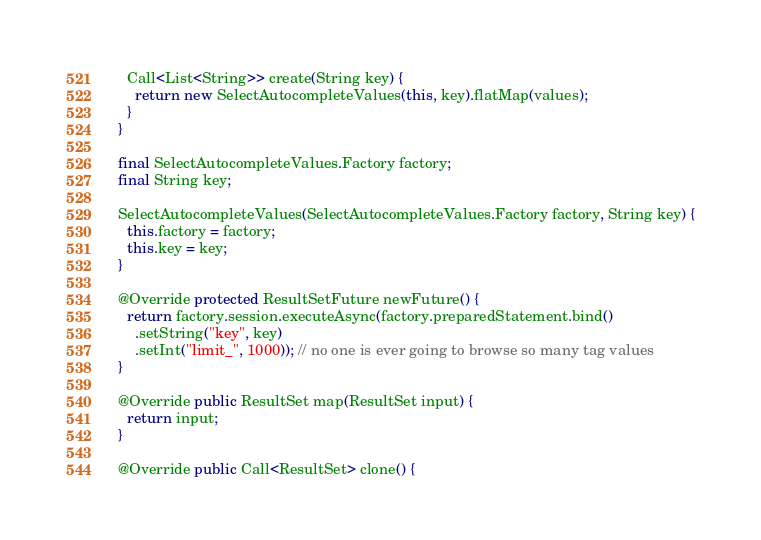<code> <loc_0><loc_0><loc_500><loc_500><_Java_>    Call<List<String>> create(String key) {
      return new SelectAutocompleteValues(this, key).flatMap(values);
    }
  }

  final SelectAutocompleteValues.Factory factory;
  final String key;

  SelectAutocompleteValues(SelectAutocompleteValues.Factory factory, String key) {
    this.factory = factory;
    this.key = key;
  }

  @Override protected ResultSetFuture newFuture() {
    return factory.session.executeAsync(factory.preparedStatement.bind()
      .setString("key", key)
      .setInt("limit_", 1000)); // no one is ever going to browse so many tag values
  }

  @Override public ResultSet map(ResultSet input) {
    return input;
  }

  @Override public Call<ResultSet> clone() {</code> 